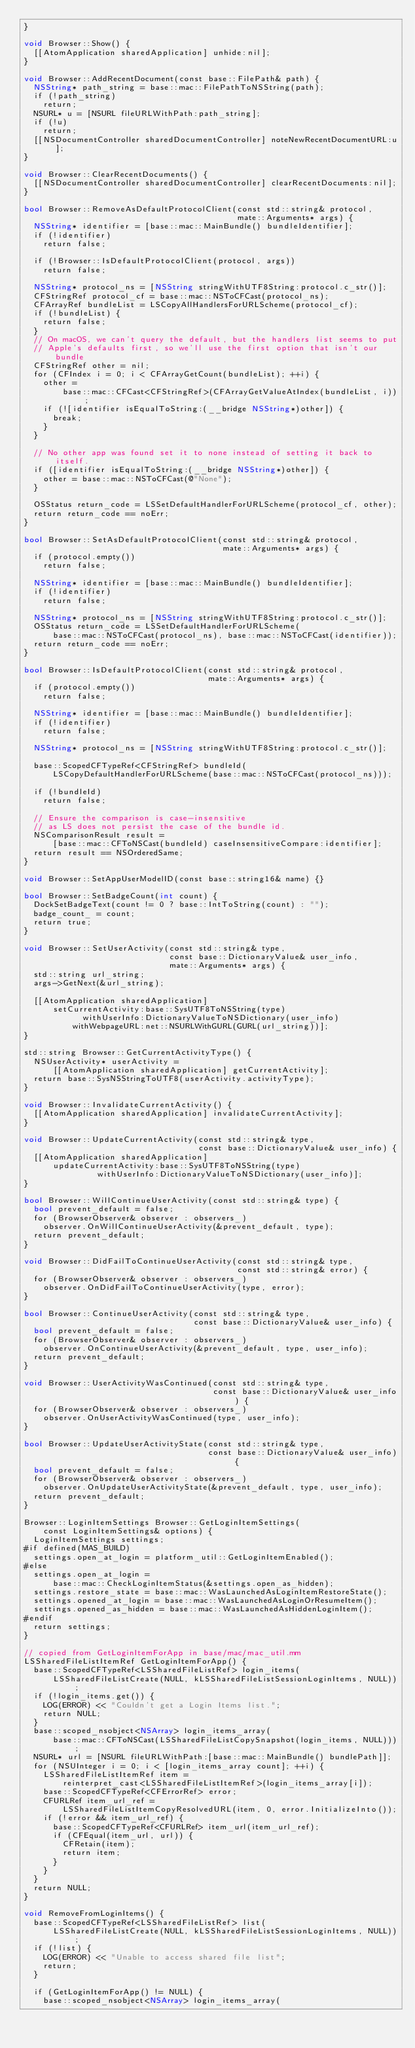<code> <loc_0><loc_0><loc_500><loc_500><_ObjectiveC_>}

void Browser::Show() {
  [[AtomApplication sharedApplication] unhide:nil];
}

void Browser::AddRecentDocument(const base::FilePath& path) {
  NSString* path_string = base::mac::FilePathToNSString(path);
  if (!path_string)
    return;
  NSURL* u = [NSURL fileURLWithPath:path_string];
  if (!u)
    return;
  [[NSDocumentController sharedDocumentController] noteNewRecentDocumentURL:u];
}

void Browser::ClearRecentDocuments() {
  [[NSDocumentController sharedDocumentController] clearRecentDocuments:nil];
}

bool Browser::RemoveAsDefaultProtocolClient(const std::string& protocol,
                                            mate::Arguments* args) {
  NSString* identifier = [base::mac::MainBundle() bundleIdentifier];
  if (!identifier)
    return false;

  if (!Browser::IsDefaultProtocolClient(protocol, args))
    return false;

  NSString* protocol_ns = [NSString stringWithUTF8String:protocol.c_str()];
  CFStringRef protocol_cf = base::mac::NSToCFCast(protocol_ns);
  CFArrayRef bundleList = LSCopyAllHandlersForURLScheme(protocol_cf);
  if (!bundleList) {
    return false;
  }
  // On macOS, we can't query the default, but the handlers list seems to put
  // Apple's defaults first, so we'll use the first option that isn't our bundle
  CFStringRef other = nil;
  for (CFIndex i = 0; i < CFArrayGetCount(bundleList); ++i) {
    other =
        base::mac::CFCast<CFStringRef>(CFArrayGetValueAtIndex(bundleList, i));
    if (![identifier isEqualToString:(__bridge NSString*)other]) {
      break;
    }
  }

  // No other app was found set it to none instead of setting it back to itself.
  if ([identifier isEqualToString:(__bridge NSString*)other]) {
    other = base::mac::NSToCFCast(@"None");
  }

  OSStatus return_code = LSSetDefaultHandlerForURLScheme(protocol_cf, other);
  return return_code == noErr;
}

bool Browser::SetAsDefaultProtocolClient(const std::string& protocol,
                                         mate::Arguments* args) {
  if (protocol.empty())
    return false;

  NSString* identifier = [base::mac::MainBundle() bundleIdentifier];
  if (!identifier)
    return false;

  NSString* protocol_ns = [NSString stringWithUTF8String:protocol.c_str()];
  OSStatus return_code = LSSetDefaultHandlerForURLScheme(
      base::mac::NSToCFCast(protocol_ns), base::mac::NSToCFCast(identifier));
  return return_code == noErr;
}

bool Browser::IsDefaultProtocolClient(const std::string& protocol,
                                      mate::Arguments* args) {
  if (protocol.empty())
    return false;

  NSString* identifier = [base::mac::MainBundle() bundleIdentifier];
  if (!identifier)
    return false;

  NSString* protocol_ns = [NSString stringWithUTF8String:protocol.c_str()];

  base::ScopedCFTypeRef<CFStringRef> bundleId(
      LSCopyDefaultHandlerForURLScheme(base::mac::NSToCFCast(protocol_ns)));

  if (!bundleId)
    return false;

  // Ensure the comparison is case-insensitive
  // as LS does not persist the case of the bundle id.
  NSComparisonResult result =
      [base::mac::CFToNSCast(bundleId) caseInsensitiveCompare:identifier];
  return result == NSOrderedSame;
}

void Browser::SetAppUserModelID(const base::string16& name) {}

bool Browser::SetBadgeCount(int count) {
  DockSetBadgeText(count != 0 ? base::IntToString(count) : "");
  badge_count_ = count;
  return true;
}

void Browser::SetUserActivity(const std::string& type,
                              const base::DictionaryValue& user_info,
                              mate::Arguments* args) {
  std::string url_string;
  args->GetNext(&url_string);

  [[AtomApplication sharedApplication]
      setCurrentActivity:base::SysUTF8ToNSString(type)
            withUserInfo:DictionaryValueToNSDictionary(user_info)
          withWebpageURL:net::NSURLWithGURL(GURL(url_string))];
}

std::string Browser::GetCurrentActivityType() {
  NSUserActivity* userActivity =
      [[AtomApplication sharedApplication] getCurrentActivity];
  return base::SysNSStringToUTF8(userActivity.activityType);
}

void Browser::InvalidateCurrentActivity() {
  [[AtomApplication sharedApplication] invalidateCurrentActivity];
}

void Browser::UpdateCurrentActivity(const std::string& type,
                                    const base::DictionaryValue& user_info) {
  [[AtomApplication sharedApplication]
      updateCurrentActivity:base::SysUTF8ToNSString(type)
               withUserInfo:DictionaryValueToNSDictionary(user_info)];
}

bool Browser::WillContinueUserActivity(const std::string& type) {
  bool prevent_default = false;
  for (BrowserObserver& observer : observers_)
    observer.OnWillContinueUserActivity(&prevent_default, type);
  return prevent_default;
}

void Browser::DidFailToContinueUserActivity(const std::string& type,
                                            const std::string& error) {
  for (BrowserObserver& observer : observers_)
    observer.OnDidFailToContinueUserActivity(type, error);
}

bool Browser::ContinueUserActivity(const std::string& type,
                                   const base::DictionaryValue& user_info) {
  bool prevent_default = false;
  for (BrowserObserver& observer : observers_)
    observer.OnContinueUserActivity(&prevent_default, type, user_info);
  return prevent_default;
}

void Browser::UserActivityWasContinued(const std::string& type,
                                       const base::DictionaryValue& user_info) {
  for (BrowserObserver& observer : observers_)
    observer.OnUserActivityWasContinued(type, user_info);
}

bool Browser::UpdateUserActivityState(const std::string& type,
                                      const base::DictionaryValue& user_info) {
  bool prevent_default = false;
  for (BrowserObserver& observer : observers_)
    observer.OnUpdateUserActivityState(&prevent_default, type, user_info);
  return prevent_default;
}

Browser::LoginItemSettings Browser::GetLoginItemSettings(
    const LoginItemSettings& options) {
  LoginItemSettings settings;
#if defined(MAS_BUILD)
  settings.open_at_login = platform_util::GetLoginItemEnabled();
#else
  settings.open_at_login =
      base::mac::CheckLoginItemStatus(&settings.open_as_hidden);
  settings.restore_state = base::mac::WasLaunchedAsLoginItemRestoreState();
  settings.opened_at_login = base::mac::WasLaunchedAsLoginOrResumeItem();
  settings.opened_as_hidden = base::mac::WasLaunchedAsHiddenLoginItem();
#endif
  return settings;
}

// copied from GetLoginItemForApp in base/mac/mac_util.mm
LSSharedFileListItemRef GetLoginItemForApp() {
  base::ScopedCFTypeRef<LSSharedFileListRef> login_items(
      LSSharedFileListCreate(NULL, kLSSharedFileListSessionLoginItems, NULL));
  if (!login_items.get()) {
    LOG(ERROR) << "Couldn't get a Login Items list.";
    return NULL;
  }
  base::scoped_nsobject<NSArray> login_items_array(
      base::mac::CFToNSCast(LSSharedFileListCopySnapshot(login_items, NULL)));
  NSURL* url = [NSURL fileURLWithPath:[base::mac::MainBundle() bundlePath]];
  for (NSUInteger i = 0; i < [login_items_array count]; ++i) {
    LSSharedFileListItemRef item =
        reinterpret_cast<LSSharedFileListItemRef>(login_items_array[i]);
    base::ScopedCFTypeRef<CFErrorRef> error;
    CFURLRef item_url_ref =
        LSSharedFileListItemCopyResolvedURL(item, 0, error.InitializeInto());
    if (!error && item_url_ref) {
      base::ScopedCFTypeRef<CFURLRef> item_url(item_url_ref);
      if (CFEqual(item_url, url)) {
        CFRetain(item);
        return item;
      }
    }
  }
  return NULL;
}

void RemoveFromLoginItems() {
  base::ScopedCFTypeRef<LSSharedFileListRef> list(
      LSSharedFileListCreate(NULL, kLSSharedFileListSessionLoginItems, NULL));
  if (!list) {
    LOG(ERROR) << "Unable to access shared file list";
    return;
  }

  if (GetLoginItemForApp() != NULL) {
    base::scoped_nsobject<NSArray> login_items_array(</code> 